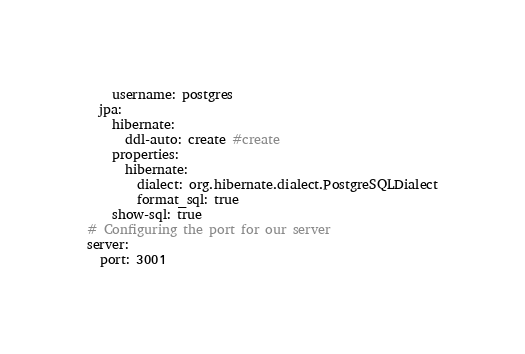Convert code to text. <code><loc_0><loc_0><loc_500><loc_500><_YAML_>    username: postgres
  jpa:
    hibernate:
      ddl-auto: create #create
    properties:
      hibernate:
        dialect: org.hibernate.dialect.PostgreSQLDialect
        format_sql: true
    show-sql: true
# Configuring the port for our server
server:
  port: 3001
</code> 